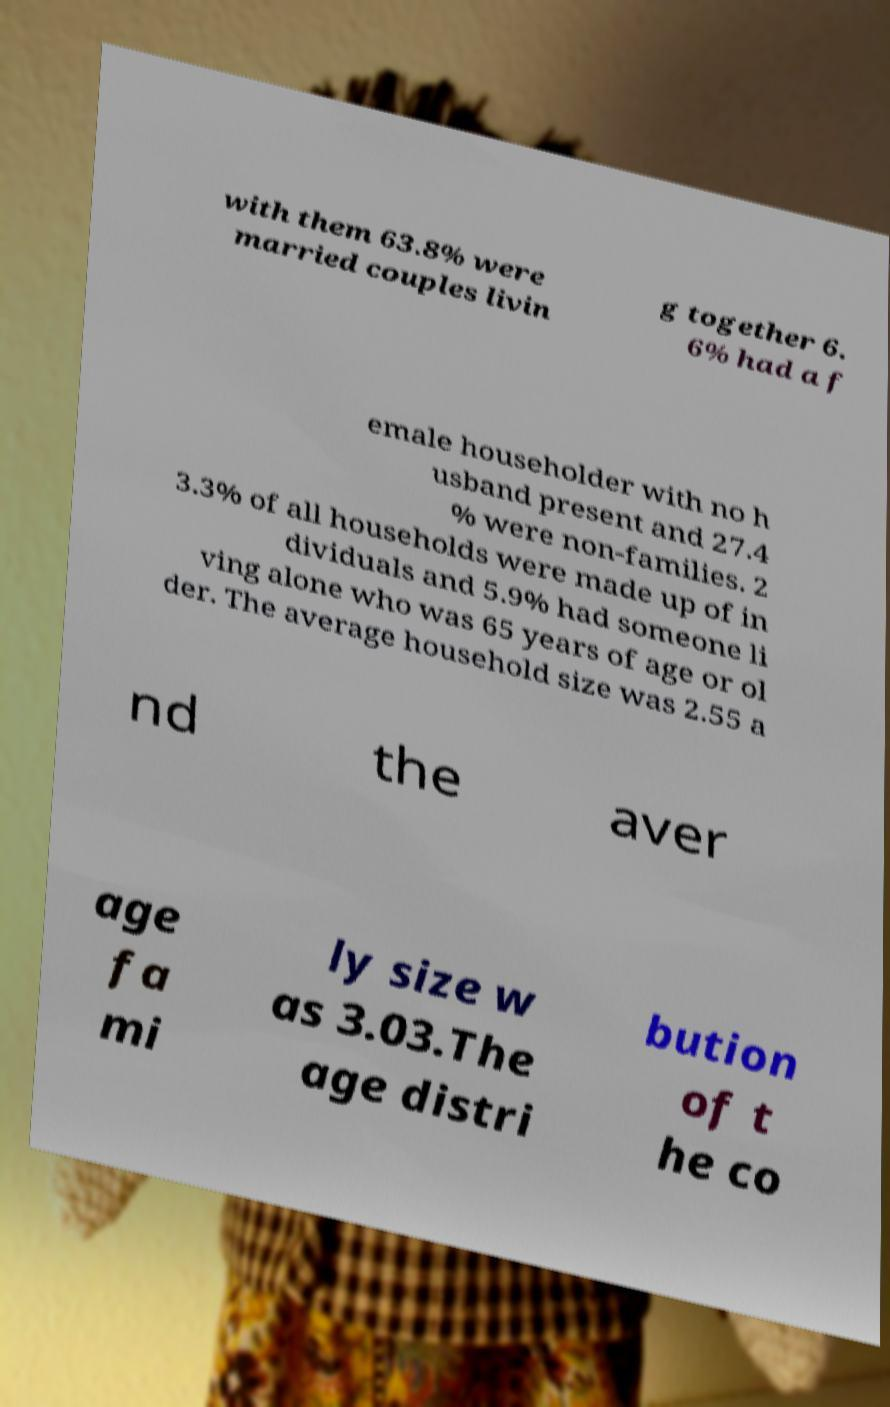Please identify and transcribe the text found in this image. with them 63.8% were married couples livin g together 6. 6% had a f emale householder with no h usband present and 27.4 % were non-families. 2 3.3% of all households were made up of in dividuals and 5.9% had someone li ving alone who was 65 years of age or ol der. The average household size was 2.55 a nd the aver age fa mi ly size w as 3.03.The age distri bution of t he co 